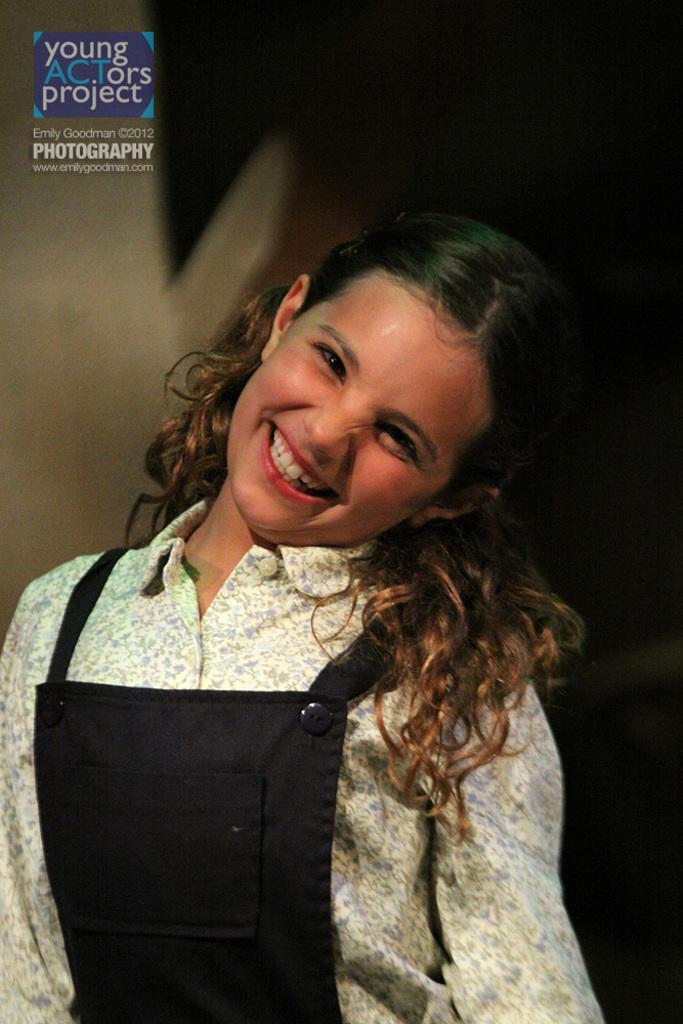Describe this image in one or two sentences. In this image we can see person in the foreground and in the background we can see the blur. 